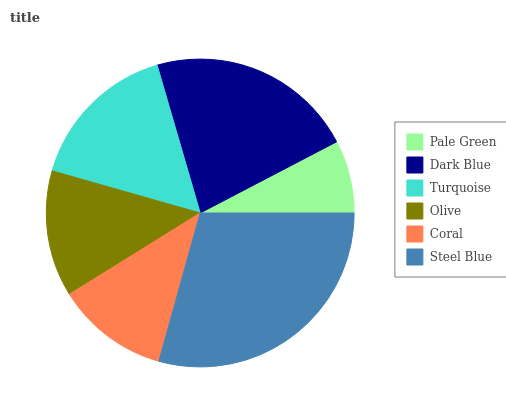Is Pale Green the minimum?
Answer yes or no. Yes. Is Steel Blue the maximum?
Answer yes or no. Yes. Is Dark Blue the minimum?
Answer yes or no. No. Is Dark Blue the maximum?
Answer yes or no. No. Is Dark Blue greater than Pale Green?
Answer yes or no. Yes. Is Pale Green less than Dark Blue?
Answer yes or no. Yes. Is Pale Green greater than Dark Blue?
Answer yes or no. No. Is Dark Blue less than Pale Green?
Answer yes or no. No. Is Turquoise the high median?
Answer yes or no. Yes. Is Olive the low median?
Answer yes or no. Yes. Is Steel Blue the high median?
Answer yes or no. No. Is Steel Blue the low median?
Answer yes or no. No. 